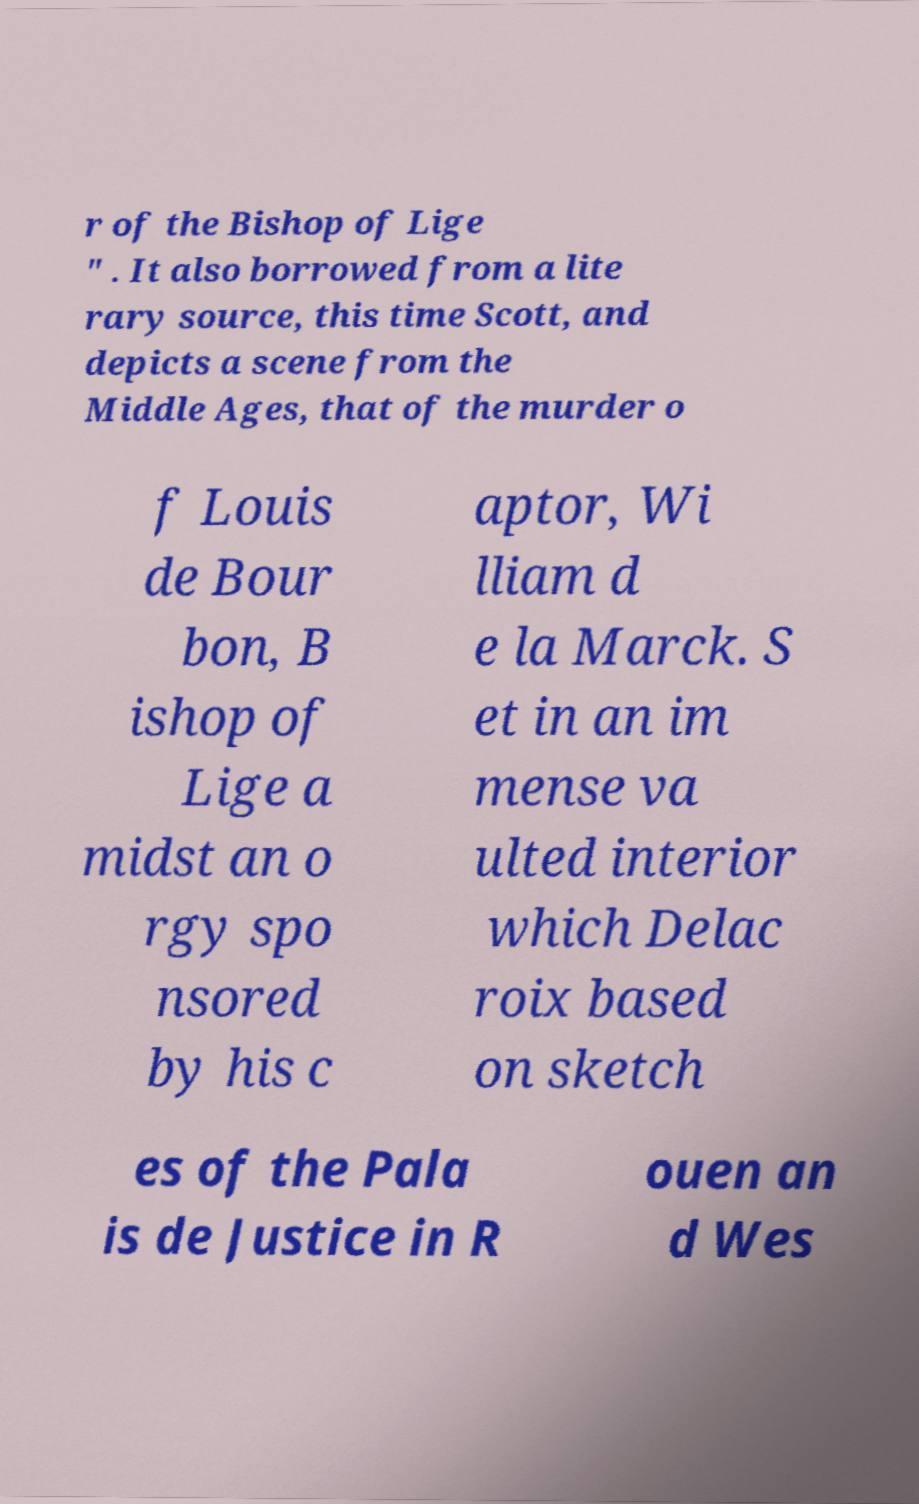For documentation purposes, I need the text within this image transcribed. Could you provide that? r of the Bishop of Lige " . It also borrowed from a lite rary source, this time Scott, and depicts a scene from the Middle Ages, that of the murder o f Louis de Bour bon, B ishop of Lige a midst an o rgy spo nsored by his c aptor, Wi lliam d e la Marck. S et in an im mense va ulted interior which Delac roix based on sketch es of the Pala is de Justice in R ouen an d Wes 